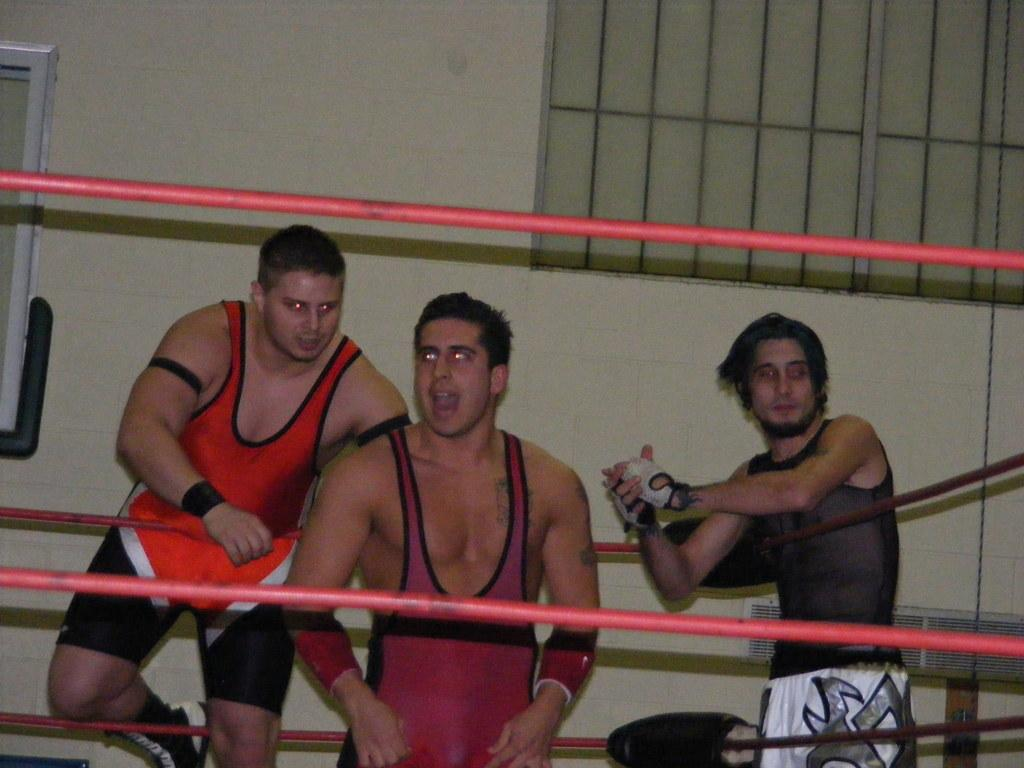How many men are standing in the image? There are three men standing in the image. What is the setting of the scene? The scene appears to be in a boxing ring. What can be seen in the background of the image? There is a wall visible in the image. What is the condition of the window in the image? There is a closed window in the image. What type of office furniture can be seen in the image? There is no office furniture present in the image; it depicts a boxing scene. How many mailboxes are visible in the image? There are no mailboxes present in the image. 